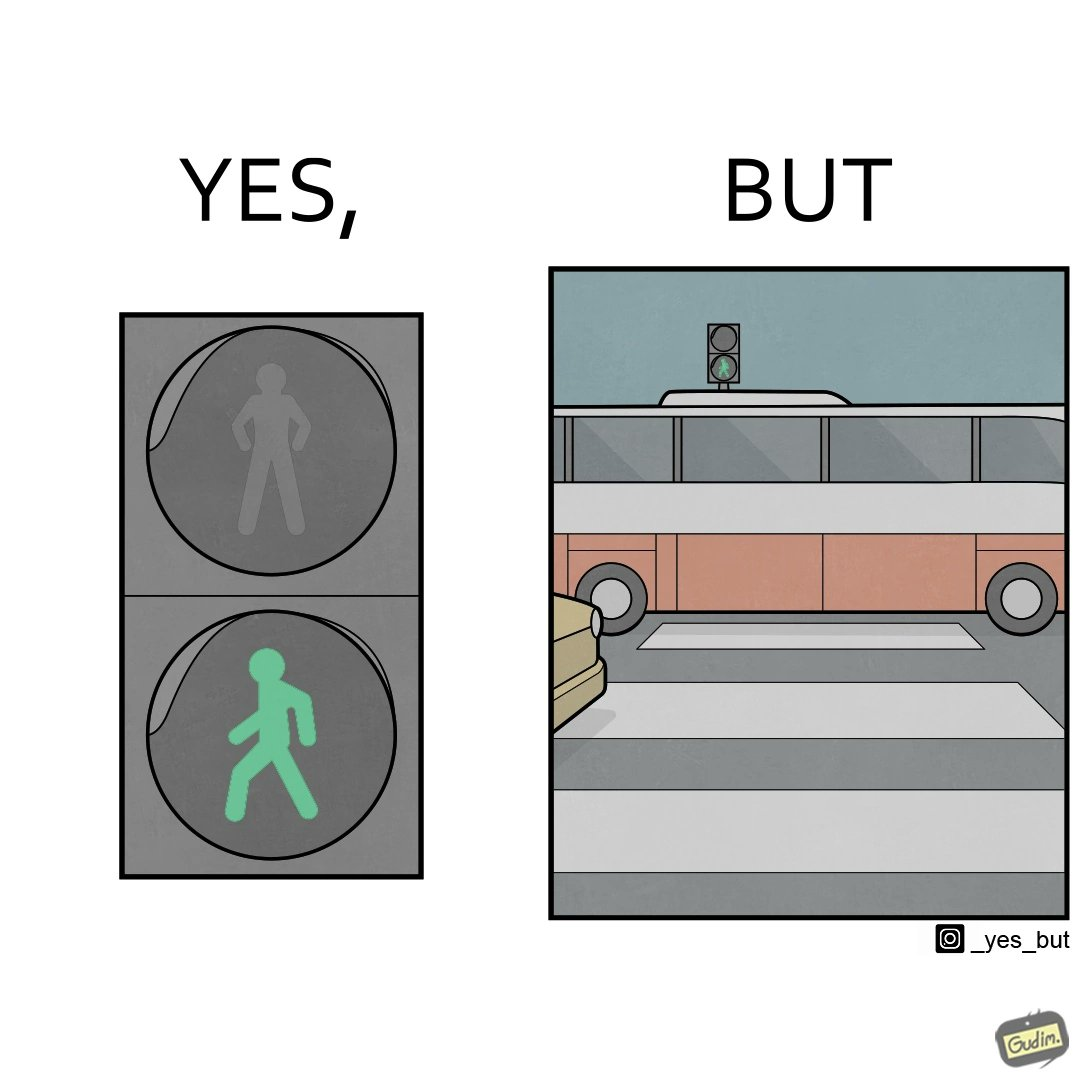Explain why this image is satirical. The image is ironic, because even when the signal is green for the pedestrians but they can't cross the road because of the vehicles standing on the zebra crossing 